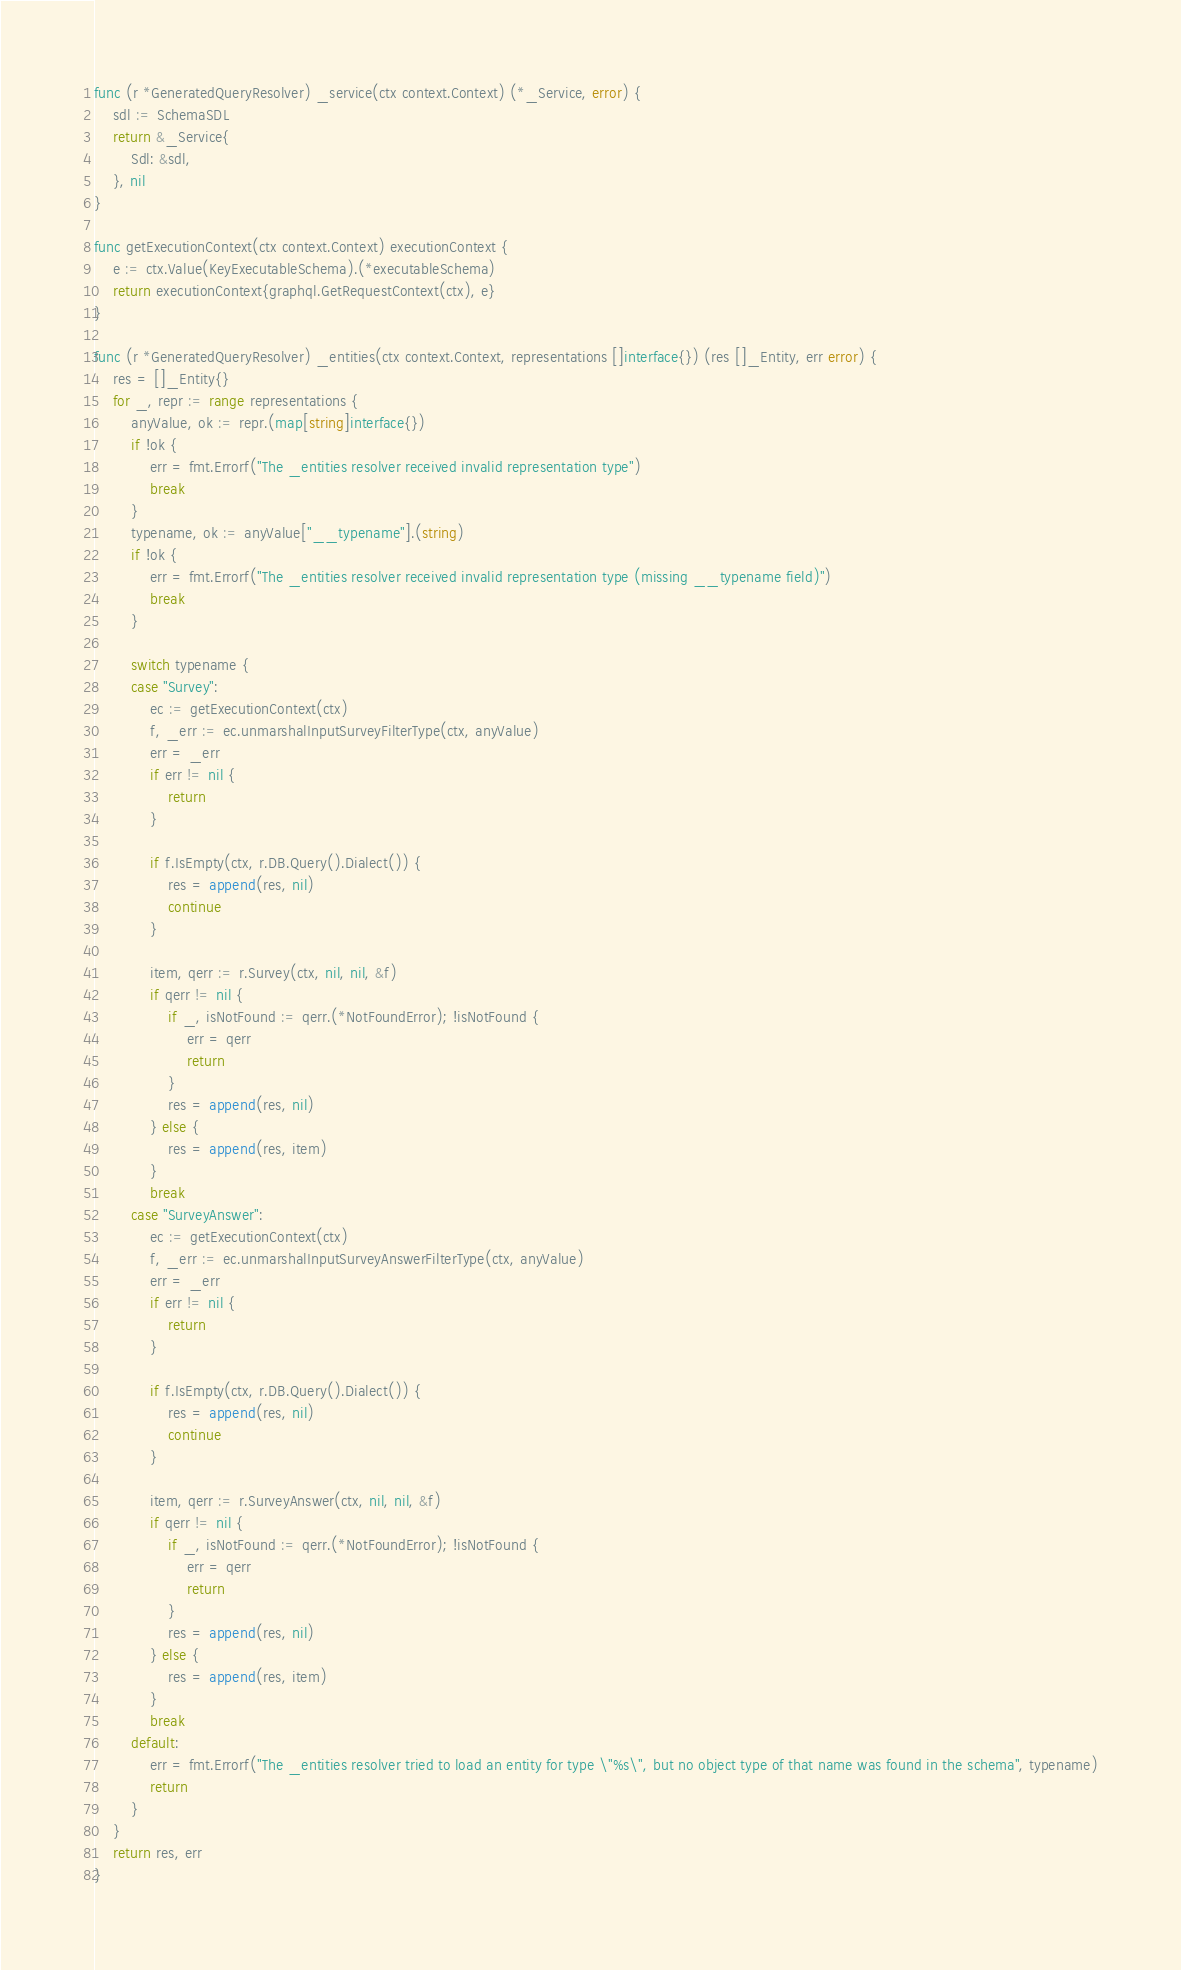<code> <loc_0><loc_0><loc_500><loc_500><_Go_>func (r *GeneratedQueryResolver) _service(ctx context.Context) (*_Service, error) {
	sdl := SchemaSDL
	return &_Service{
		Sdl: &sdl,
	}, nil
}

func getExecutionContext(ctx context.Context) executionContext {
	e := ctx.Value(KeyExecutableSchema).(*executableSchema)
	return executionContext{graphql.GetRequestContext(ctx), e}
}

func (r *GeneratedQueryResolver) _entities(ctx context.Context, representations []interface{}) (res []_Entity, err error) {
	res = []_Entity{}
	for _, repr := range representations {
		anyValue, ok := repr.(map[string]interface{})
		if !ok {
			err = fmt.Errorf("The _entities resolver received invalid representation type")
			break
		}
		typename, ok := anyValue["__typename"].(string)
		if !ok {
			err = fmt.Errorf("The _entities resolver received invalid representation type (missing __typename field)")
			break
		}

		switch typename {
		case "Survey":
			ec := getExecutionContext(ctx)
			f, _err := ec.unmarshalInputSurveyFilterType(ctx, anyValue)
			err = _err
			if err != nil {
				return
			}

			if f.IsEmpty(ctx, r.DB.Query().Dialect()) {
				res = append(res, nil)
				continue
			}

			item, qerr := r.Survey(ctx, nil, nil, &f)
			if qerr != nil {
				if _, isNotFound := qerr.(*NotFoundError); !isNotFound {
					err = qerr
					return
				}
				res = append(res, nil)
			} else {
				res = append(res, item)
			}
			break
		case "SurveyAnswer":
			ec := getExecutionContext(ctx)
			f, _err := ec.unmarshalInputSurveyAnswerFilterType(ctx, anyValue)
			err = _err
			if err != nil {
				return
			}

			if f.IsEmpty(ctx, r.DB.Query().Dialect()) {
				res = append(res, nil)
				continue
			}

			item, qerr := r.SurveyAnswer(ctx, nil, nil, &f)
			if qerr != nil {
				if _, isNotFound := qerr.(*NotFoundError); !isNotFound {
					err = qerr
					return
				}
				res = append(res, nil)
			} else {
				res = append(res, item)
			}
			break
		default:
			err = fmt.Errorf("The _entities resolver tried to load an entity for type \"%s\", but no object type of that name was found in the schema", typename)
			return
		}
	}
	return res, err
}
</code> 